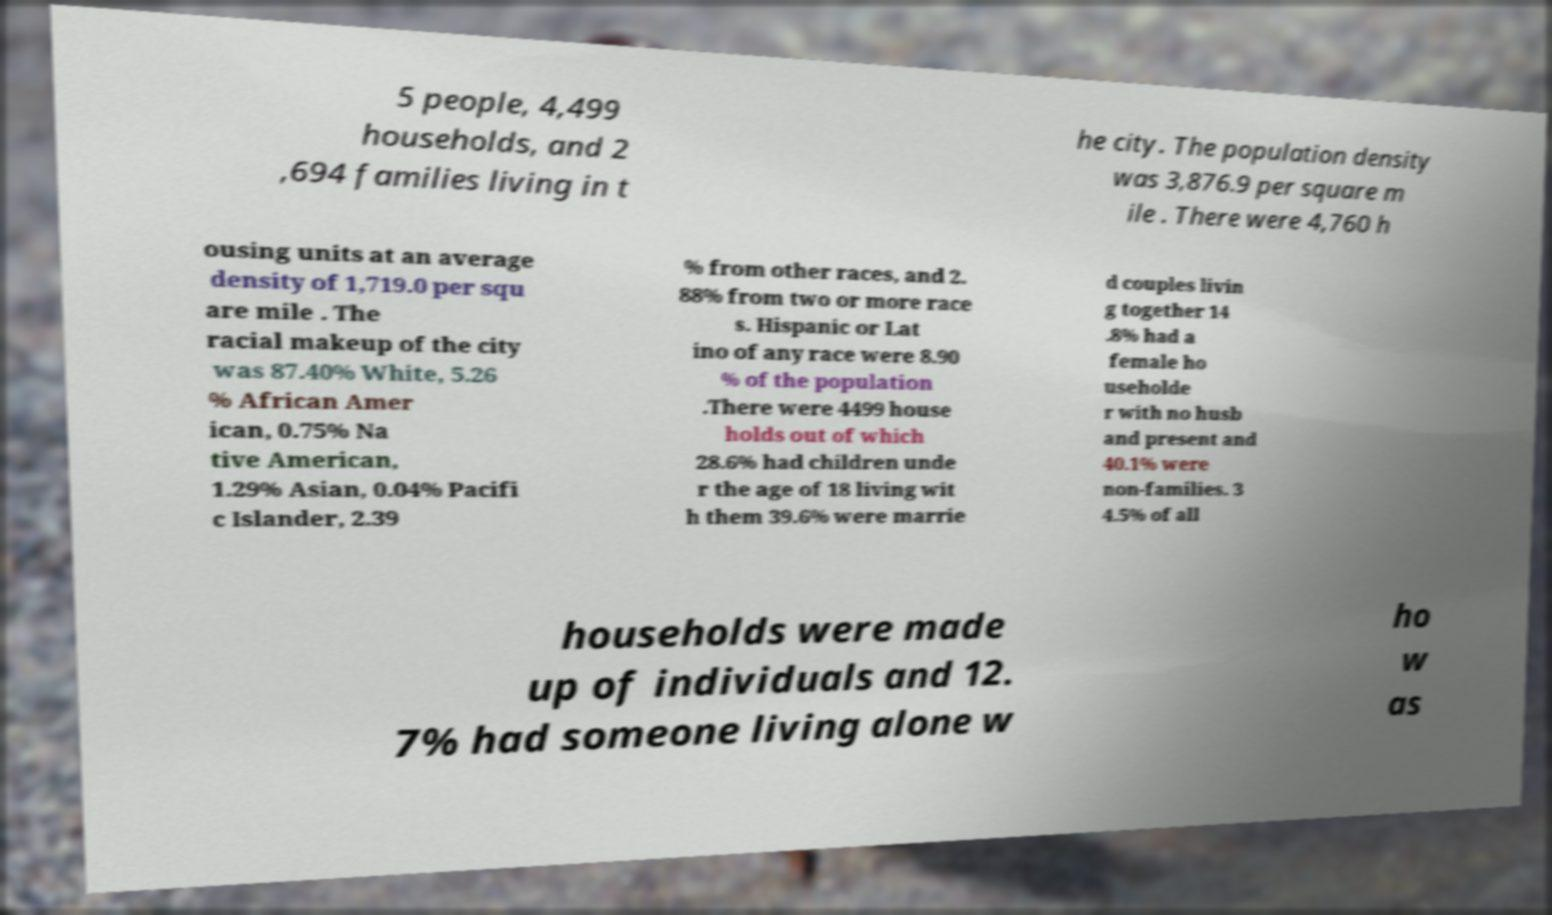Can you read and provide the text displayed in the image?This photo seems to have some interesting text. Can you extract and type it out for me? 5 people, 4,499 households, and 2 ,694 families living in t he city. The population density was 3,876.9 per square m ile . There were 4,760 h ousing units at an average density of 1,719.0 per squ are mile . The racial makeup of the city was 87.40% White, 5.26 % African Amer ican, 0.75% Na tive American, 1.29% Asian, 0.04% Pacifi c Islander, 2.39 % from other races, and 2. 88% from two or more race s. Hispanic or Lat ino of any race were 8.90 % of the population .There were 4499 house holds out of which 28.6% had children unde r the age of 18 living wit h them 39.6% were marrie d couples livin g together 14 .8% had a female ho useholde r with no husb and present and 40.1% were non-families. 3 4.5% of all households were made up of individuals and 12. 7% had someone living alone w ho w as 